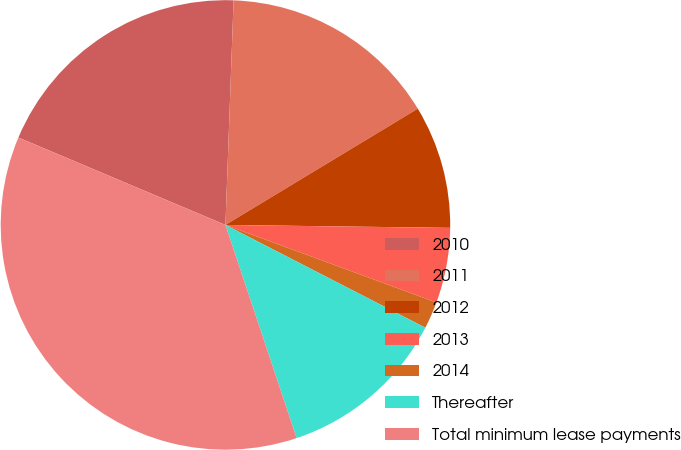Convert chart to OTSL. <chart><loc_0><loc_0><loc_500><loc_500><pie_chart><fcel>2010<fcel>2011<fcel>2012<fcel>2013<fcel>2014<fcel>Thereafter<fcel>Total minimum lease payments<nl><fcel>19.22%<fcel>15.77%<fcel>8.86%<fcel>5.4%<fcel>1.95%<fcel>12.31%<fcel>36.49%<nl></chart> 